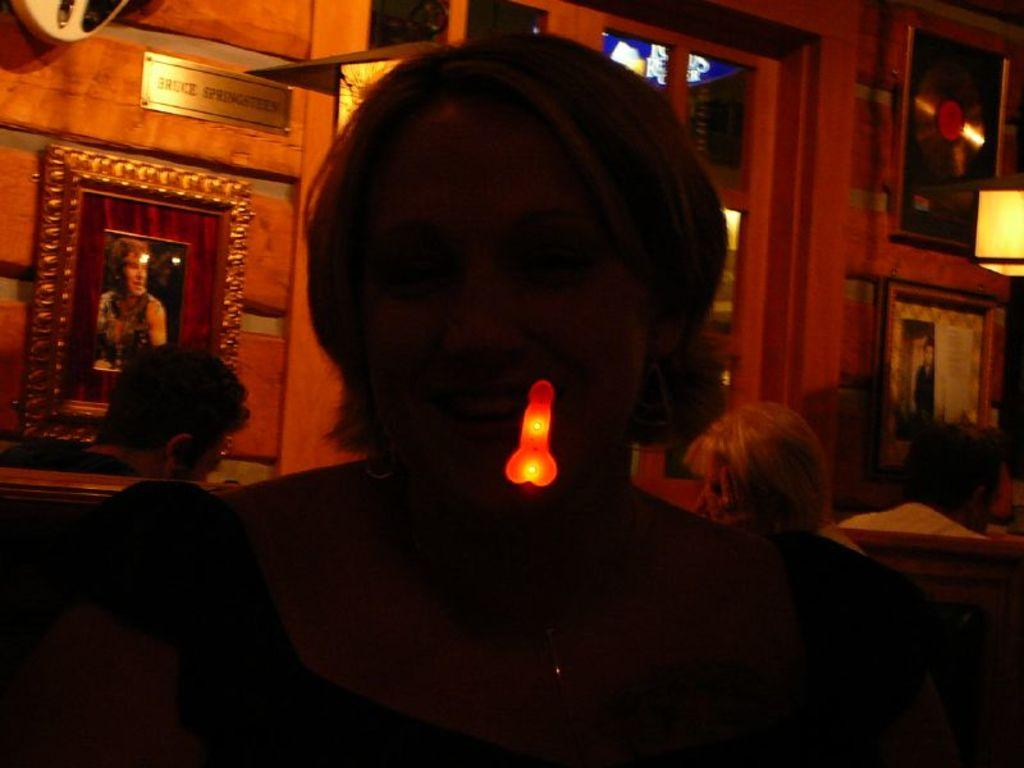Who or what is present in the image? There are people in the image. What can be seen in the image that provides illumination? There are lights in the image. What type of decorative items are on the wall? There are photo frames on the wall. What is the purpose of the board with text in the image? The board with text in the image may be used for displaying information or announcements. What type of watch can be seen on the person's wrist in the image? There is no watch visible on anyone's wrist in the image. What season is depicted in the image, considering the presence of winter clothing? The image does not show any winter clothing, so it cannot be determined that the season is winter. 